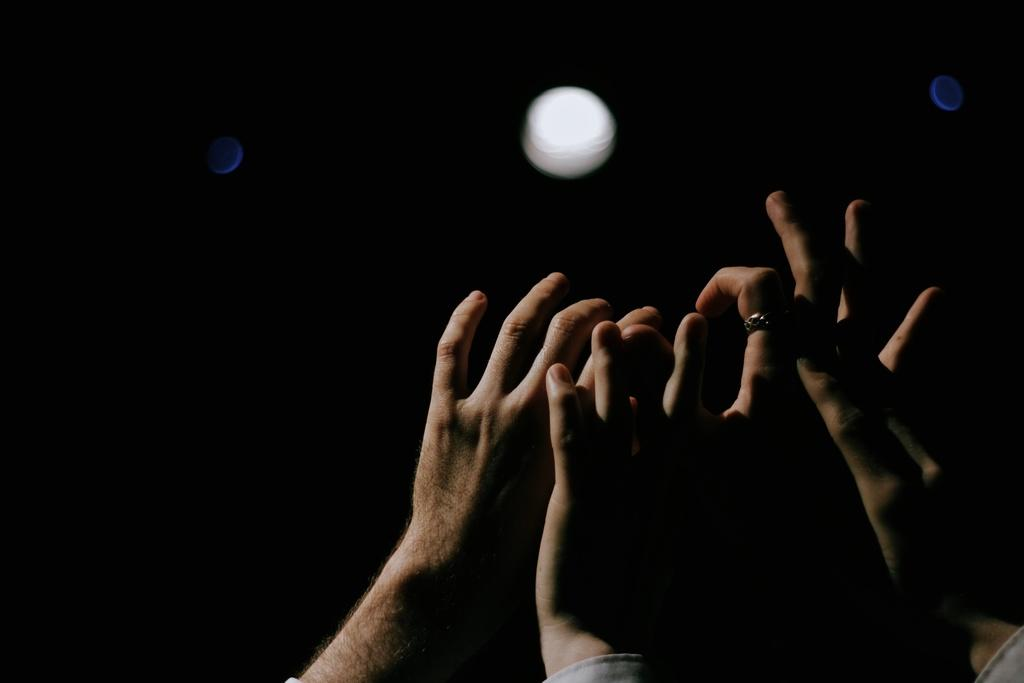What is happening with the hands in the image? The hands are rising above in the image. What time of day was the image taken? The image was taken at night. What can be seen in the background of the image? There appears to be a moon in the background of the image. What type of support can be seen in the image? There is no support visible in the image. Is there a train passing by in the image? There is no train present in the image. 